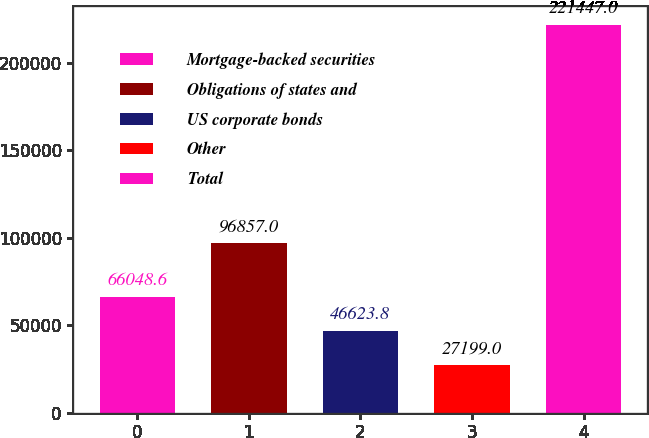<chart> <loc_0><loc_0><loc_500><loc_500><bar_chart><fcel>Mortgage-backed securities<fcel>Obligations of states and<fcel>US corporate bonds<fcel>Other<fcel>Total<nl><fcel>66048.6<fcel>96857<fcel>46623.8<fcel>27199<fcel>221447<nl></chart> 